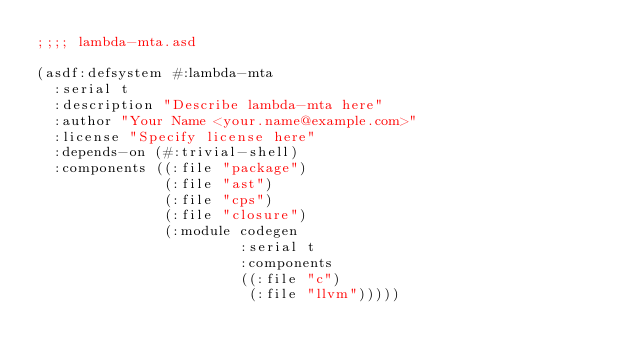<code> <loc_0><loc_0><loc_500><loc_500><_Lisp_>;;;; lambda-mta.asd

(asdf:defsystem #:lambda-mta
  :serial t
  :description "Describe lambda-mta here"
  :author "Your Name <your.name@example.com>"
  :license "Specify license here"
  :depends-on (#:trivial-shell)
  :components ((:file "package")
               (:file "ast")
               (:file "cps")
               (:file "closure")
               (:module codegen
                        :serial t
                        :components
                        ((:file "c")
                         (:file "llvm")))))

</code> 